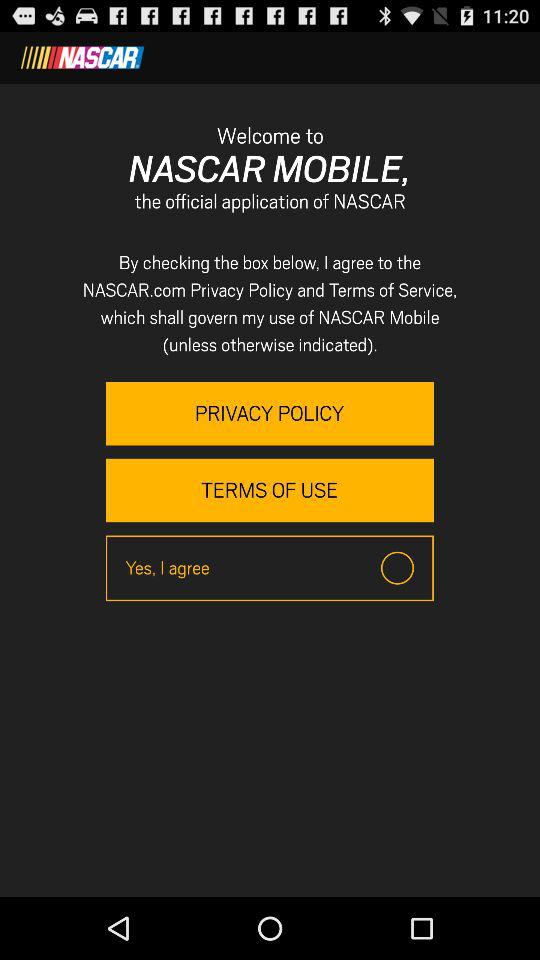What is the status of "Yes, I agree"? The status is off. 